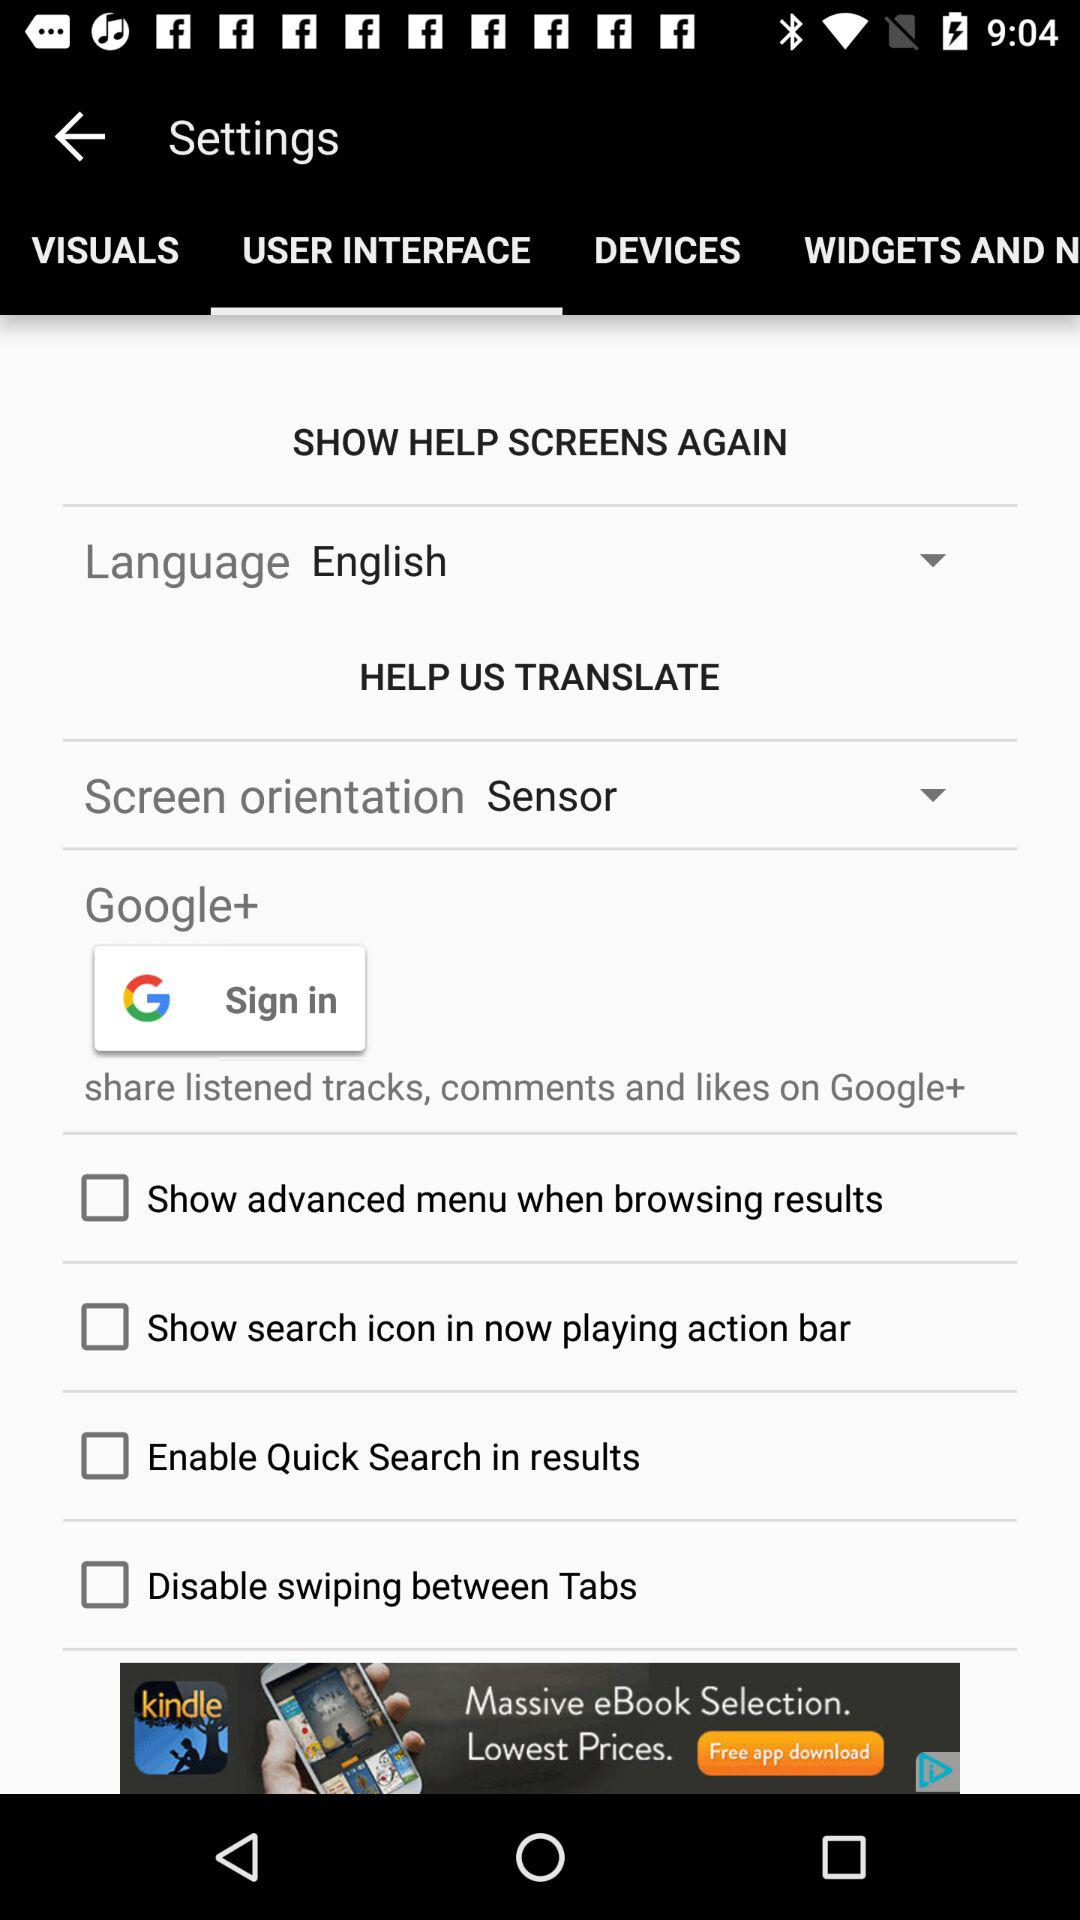What is the status of the enable quick search in results? The status is "off". 